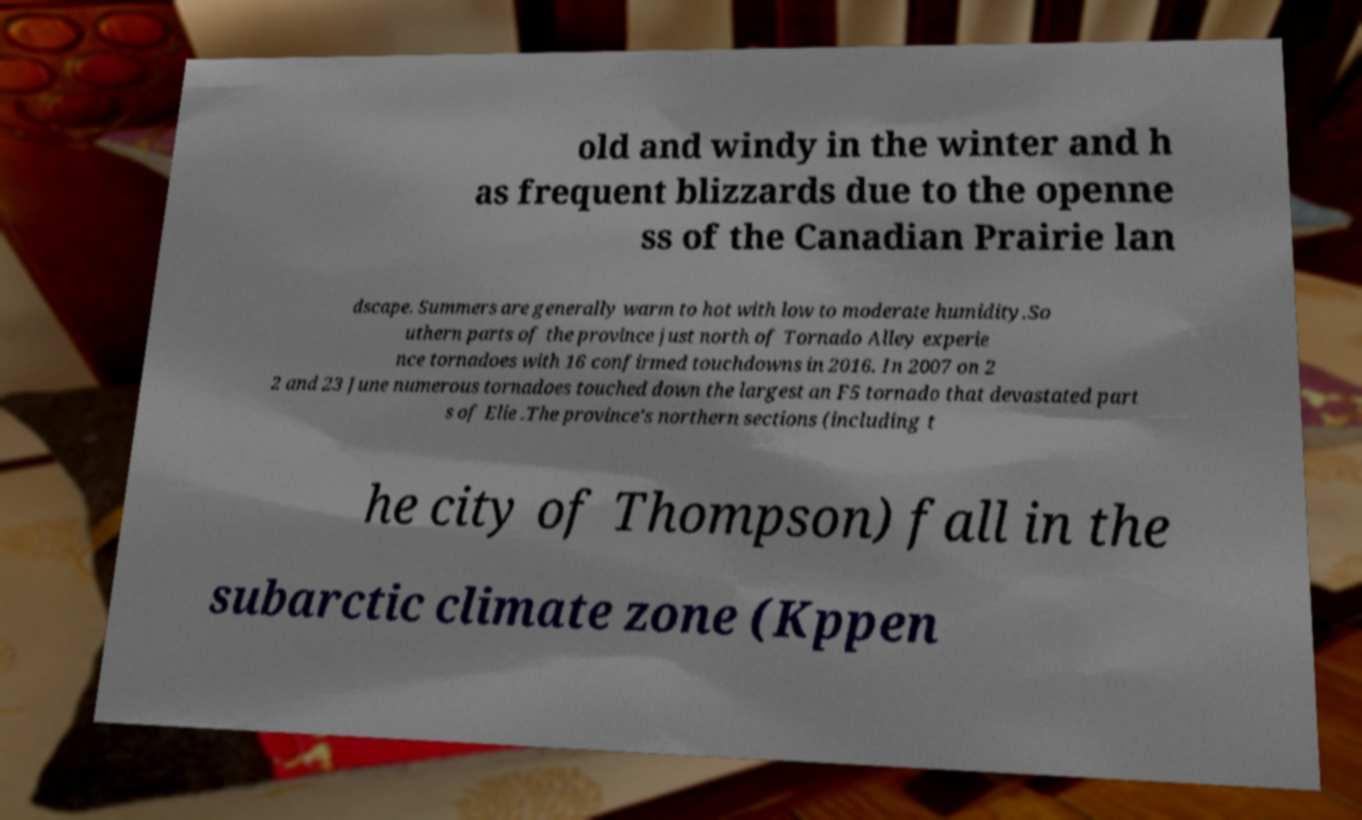Can you read and provide the text displayed in the image?This photo seems to have some interesting text. Can you extract and type it out for me? old and windy in the winter and h as frequent blizzards due to the openne ss of the Canadian Prairie lan dscape. Summers are generally warm to hot with low to moderate humidity.So uthern parts of the province just north of Tornado Alley experie nce tornadoes with 16 confirmed touchdowns in 2016. In 2007 on 2 2 and 23 June numerous tornadoes touched down the largest an F5 tornado that devastated part s of Elie .The province's northern sections (including t he city of Thompson) fall in the subarctic climate zone (Kppen 